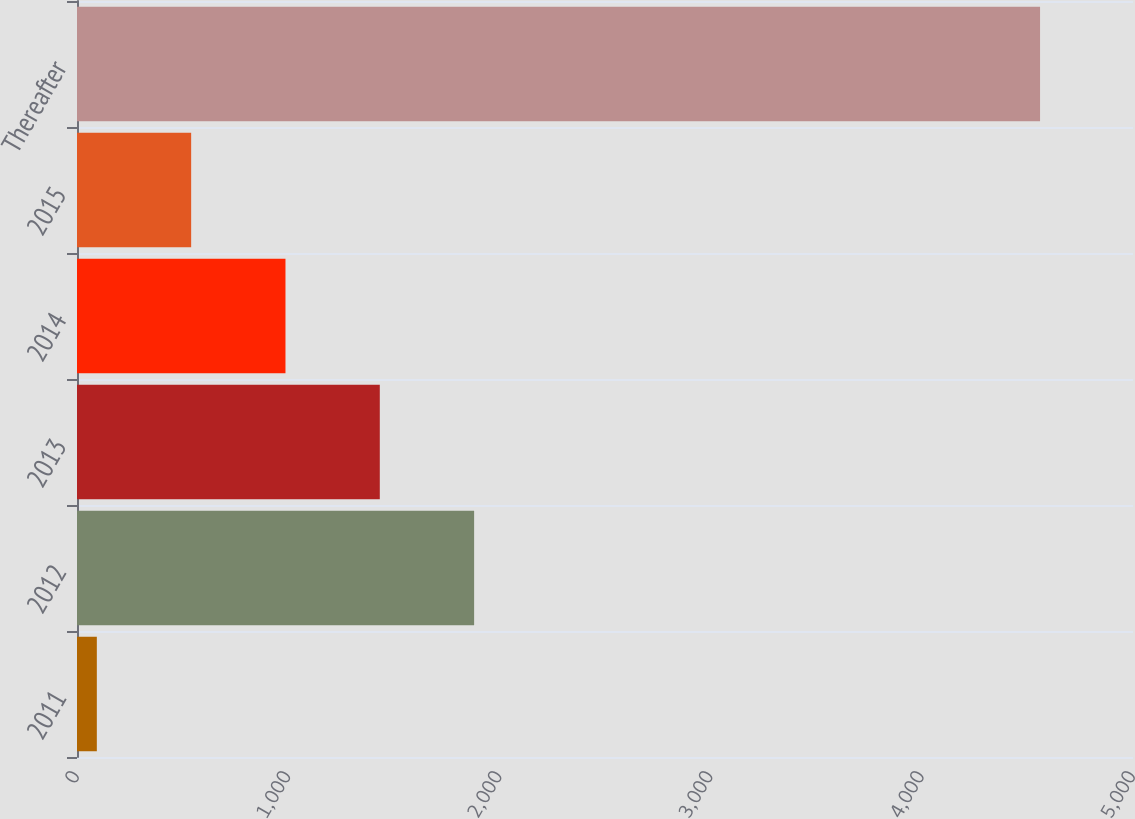Convert chart. <chart><loc_0><loc_0><loc_500><loc_500><bar_chart><fcel>2011<fcel>2012<fcel>2013<fcel>2014<fcel>2015<fcel>Thereafter<nl><fcel>93.9<fcel>1880.3<fcel>1433.7<fcel>987.1<fcel>540.5<fcel>4559.9<nl></chart> 